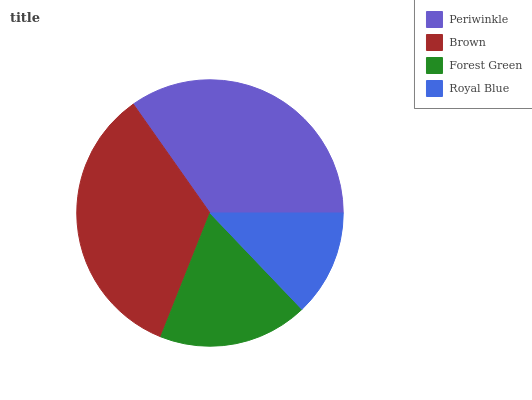Is Royal Blue the minimum?
Answer yes or no. Yes. Is Periwinkle the maximum?
Answer yes or no. Yes. Is Brown the minimum?
Answer yes or no. No. Is Brown the maximum?
Answer yes or no. No. Is Periwinkle greater than Brown?
Answer yes or no. Yes. Is Brown less than Periwinkle?
Answer yes or no. Yes. Is Brown greater than Periwinkle?
Answer yes or no. No. Is Periwinkle less than Brown?
Answer yes or no. No. Is Brown the high median?
Answer yes or no. Yes. Is Forest Green the low median?
Answer yes or no. Yes. Is Periwinkle the high median?
Answer yes or no. No. Is Periwinkle the low median?
Answer yes or no. No. 